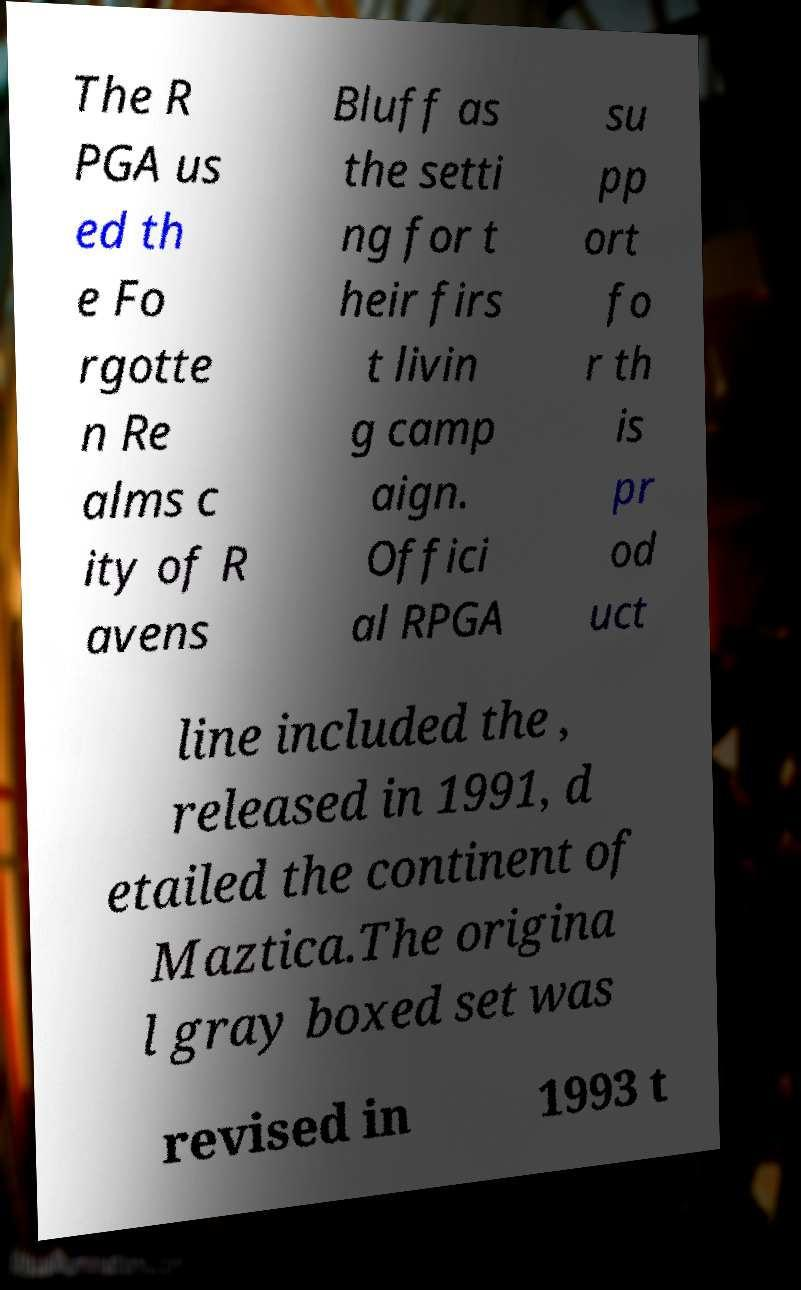Please identify and transcribe the text found in this image. The R PGA us ed th e Fo rgotte n Re alms c ity of R avens Bluff as the setti ng for t heir firs t livin g camp aign. Offici al RPGA su pp ort fo r th is pr od uct line included the , released in 1991, d etailed the continent of Maztica.The origina l gray boxed set was revised in 1993 t 